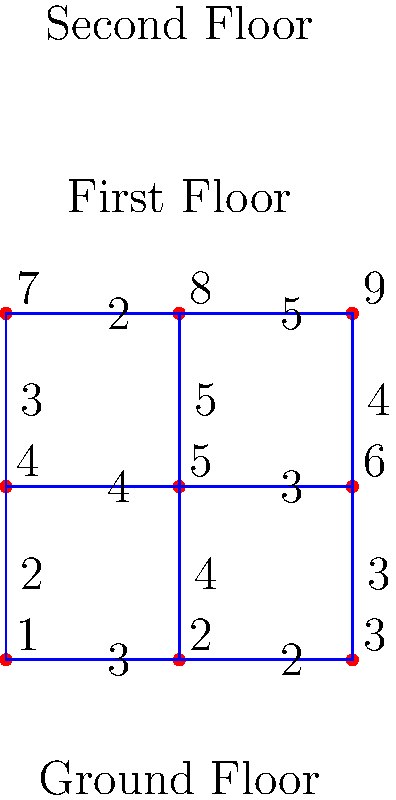In a multi-story building under construction, you need to transport materials from the ground floor to the second floor. The graph represents the possible routes between different points in the building, with the numbers on the edges indicating the time (in minutes) required to move between those points. What is the shortest time required to transport materials from point 1 to point 9? To find the shortest time required to transport materials from point 1 to point 9, we need to use Dijkstra's algorithm or a similar shortest path algorithm. Let's solve this step-by-step:

1. Identify all possible paths from point 1 to point 9:
   a. 1 → 2 → 3 → 6 → 9
   b. 1 → 2 → 5 → 8 → 9
   c. 1 → 4 → 5 → 8 → 9
   d. 1 → 4 → 7 → 8 → 9

2. Calculate the total time for each path:
   a. 1 → 2 → 3 → 6 → 9 = 3 + 2 + 3 + 4 = 12 minutes
   b. 1 → 2 → 5 → 8 → 9 = 3 + 3 + 4 + 5 = 15 minutes
   c. 1 → 4 → 5 → 8 → 9 = 2 + 4 + 4 + 5 = 15 minutes
   d. 1 → 4 → 7 → 8 → 9 = 2 + 5 + 2 + 5 = 14 minutes

3. Compare the total times:
   The shortest path is 1 → 2 → 3 → 6 → 9, which takes 12 minutes.

Therefore, the shortest time required to transport materials from point 1 to point 9 is 12 minutes.
Answer: 12 minutes 